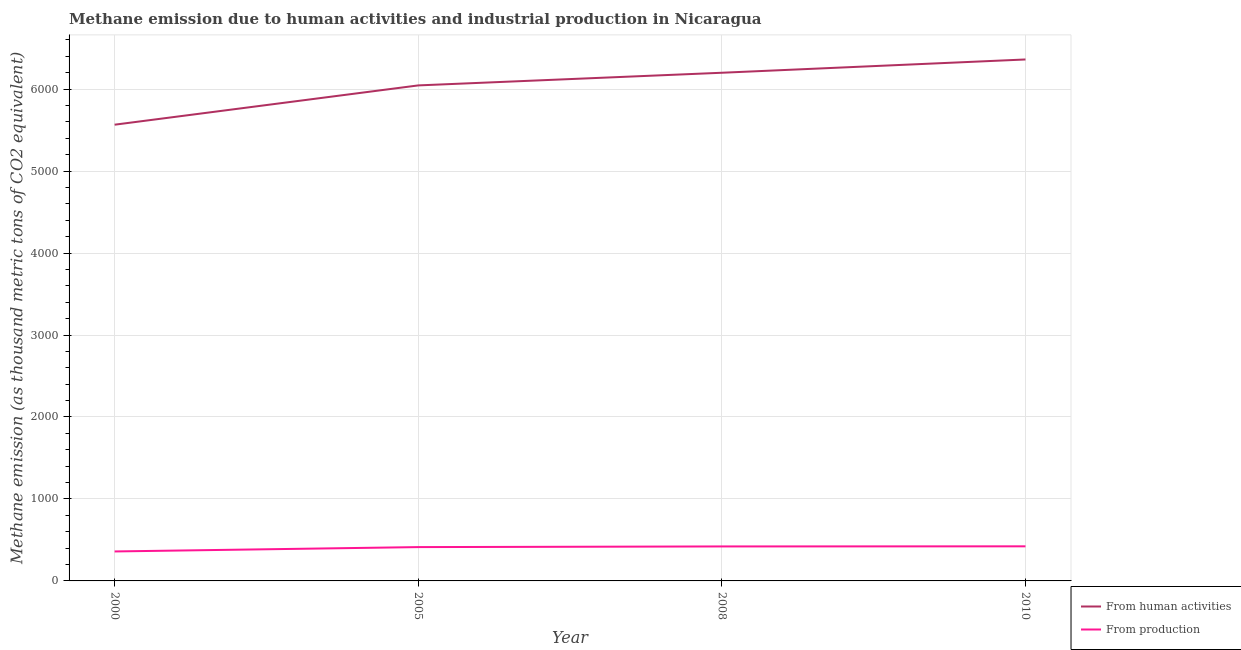Does the line corresponding to amount of emissions generated from industries intersect with the line corresponding to amount of emissions from human activities?
Provide a succinct answer. No. Is the number of lines equal to the number of legend labels?
Your response must be concise. Yes. What is the amount of emissions from human activities in 2000?
Your answer should be very brief. 5565.7. Across all years, what is the maximum amount of emissions generated from industries?
Provide a short and direct response. 422.1. Across all years, what is the minimum amount of emissions generated from industries?
Give a very brief answer. 359.5. In which year was the amount of emissions from human activities maximum?
Ensure brevity in your answer.  2010. What is the total amount of emissions from human activities in the graph?
Your response must be concise. 2.42e+04. What is the difference between the amount of emissions from human activities in 2008 and that in 2010?
Provide a short and direct response. -161.9. What is the difference between the amount of emissions generated from industries in 2010 and the amount of emissions from human activities in 2005?
Give a very brief answer. -5622.9. What is the average amount of emissions from human activities per year?
Your answer should be compact. 6042.9. In the year 2010, what is the difference between the amount of emissions generated from industries and amount of emissions from human activities?
Your response must be concise. -5939.3. In how many years, is the amount of emissions from human activities greater than 1000 thousand metric tons?
Your response must be concise. 4. What is the ratio of the amount of emissions generated from industries in 2005 to that in 2010?
Offer a terse response. 0.98. What is the difference between the highest and the second highest amount of emissions from human activities?
Your answer should be very brief. 161.9. What is the difference between the highest and the lowest amount of emissions generated from industries?
Provide a short and direct response. 62.6. In how many years, is the amount of emissions from human activities greater than the average amount of emissions from human activities taken over all years?
Offer a terse response. 3. Is the sum of the amount of emissions generated from industries in 2000 and 2008 greater than the maximum amount of emissions from human activities across all years?
Make the answer very short. No. Does the amount of emissions generated from industries monotonically increase over the years?
Offer a very short reply. Yes. Is the amount of emissions generated from industries strictly greater than the amount of emissions from human activities over the years?
Your answer should be compact. No. How many years are there in the graph?
Keep it short and to the point. 4. Are the values on the major ticks of Y-axis written in scientific E-notation?
Provide a short and direct response. No. How many legend labels are there?
Make the answer very short. 2. What is the title of the graph?
Your answer should be very brief. Methane emission due to human activities and industrial production in Nicaragua. What is the label or title of the X-axis?
Keep it short and to the point. Year. What is the label or title of the Y-axis?
Give a very brief answer. Methane emission (as thousand metric tons of CO2 equivalent). What is the Methane emission (as thousand metric tons of CO2 equivalent) in From human activities in 2000?
Provide a short and direct response. 5565.7. What is the Methane emission (as thousand metric tons of CO2 equivalent) of From production in 2000?
Give a very brief answer. 359.5. What is the Methane emission (as thousand metric tons of CO2 equivalent) in From human activities in 2005?
Make the answer very short. 6045. What is the Methane emission (as thousand metric tons of CO2 equivalent) in From production in 2005?
Give a very brief answer. 412.7. What is the Methane emission (as thousand metric tons of CO2 equivalent) in From human activities in 2008?
Give a very brief answer. 6199.5. What is the Methane emission (as thousand metric tons of CO2 equivalent) in From production in 2008?
Your answer should be very brief. 420.7. What is the Methane emission (as thousand metric tons of CO2 equivalent) in From human activities in 2010?
Provide a short and direct response. 6361.4. What is the Methane emission (as thousand metric tons of CO2 equivalent) of From production in 2010?
Make the answer very short. 422.1. Across all years, what is the maximum Methane emission (as thousand metric tons of CO2 equivalent) in From human activities?
Offer a terse response. 6361.4. Across all years, what is the maximum Methane emission (as thousand metric tons of CO2 equivalent) of From production?
Your answer should be very brief. 422.1. Across all years, what is the minimum Methane emission (as thousand metric tons of CO2 equivalent) in From human activities?
Make the answer very short. 5565.7. Across all years, what is the minimum Methane emission (as thousand metric tons of CO2 equivalent) in From production?
Make the answer very short. 359.5. What is the total Methane emission (as thousand metric tons of CO2 equivalent) in From human activities in the graph?
Make the answer very short. 2.42e+04. What is the total Methane emission (as thousand metric tons of CO2 equivalent) in From production in the graph?
Offer a very short reply. 1615. What is the difference between the Methane emission (as thousand metric tons of CO2 equivalent) of From human activities in 2000 and that in 2005?
Provide a succinct answer. -479.3. What is the difference between the Methane emission (as thousand metric tons of CO2 equivalent) of From production in 2000 and that in 2005?
Your answer should be compact. -53.2. What is the difference between the Methane emission (as thousand metric tons of CO2 equivalent) in From human activities in 2000 and that in 2008?
Offer a terse response. -633.8. What is the difference between the Methane emission (as thousand metric tons of CO2 equivalent) in From production in 2000 and that in 2008?
Provide a short and direct response. -61.2. What is the difference between the Methane emission (as thousand metric tons of CO2 equivalent) of From human activities in 2000 and that in 2010?
Keep it short and to the point. -795.7. What is the difference between the Methane emission (as thousand metric tons of CO2 equivalent) in From production in 2000 and that in 2010?
Your answer should be compact. -62.6. What is the difference between the Methane emission (as thousand metric tons of CO2 equivalent) of From human activities in 2005 and that in 2008?
Your answer should be compact. -154.5. What is the difference between the Methane emission (as thousand metric tons of CO2 equivalent) in From human activities in 2005 and that in 2010?
Your answer should be compact. -316.4. What is the difference between the Methane emission (as thousand metric tons of CO2 equivalent) in From human activities in 2008 and that in 2010?
Offer a very short reply. -161.9. What is the difference between the Methane emission (as thousand metric tons of CO2 equivalent) of From production in 2008 and that in 2010?
Ensure brevity in your answer.  -1.4. What is the difference between the Methane emission (as thousand metric tons of CO2 equivalent) in From human activities in 2000 and the Methane emission (as thousand metric tons of CO2 equivalent) in From production in 2005?
Ensure brevity in your answer.  5153. What is the difference between the Methane emission (as thousand metric tons of CO2 equivalent) in From human activities in 2000 and the Methane emission (as thousand metric tons of CO2 equivalent) in From production in 2008?
Ensure brevity in your answer.  5145. What is the difference between the Methane emission (as thousand metric tons of CO2 equivalent) of From human activities in 2000 and the Methane emission (as thousand metric tons of CO2 equivalent) of From production in 2010?
Offer a terse response. 5143.6. What is the difference between the Methane emission (as thousand metric tons of CO2 equivalent) of From human activities in 2005 and the Methane emission (as thousand metric tons of CO2 equivalent) of From production in 2008?
Give a very brief answer. 5624.3. What is the difference between the Methane emission (as thousand metric tons of CO2 equivalent) in From human activities in 2005 and the Methane emission (as thousand metric tons of CO2 equivalent) in From production in 2010?
Give a very brief answer. 5622.9. What is the difference between the Methane emission (as thousand metric tons of CO2 equivalent) in From human activities in 2008 and the Methane emission (as thousand metric tons of CO2 equivalent) in From production in 2010?
Your answer should be very brief. 5777.4. What is the average Methane emission (as thousand metric tons of CO2 equivalent) of From human activities per year?
Offer a very short reply. 6042.9. What is the average Methane emission (as thousand metric tons of CO2 equivalent) of From production per year?
Offer a terse response. 403.75. In the year 2000, what is the difference between the Methane emission (as thousand metric tons of CO2 equivalent) in From human activities and Methane emission (as thousand metric tons of CO2 equivalent) in From production?
Your answer should be compact. 5206.2. In the year 2005, what is the difference between the Methane emission (as thousand metric tons of CO2 equivalent) in From human activities and Methane emission (as thousand metric tons of CO2 equivalent) in From production?
Offer a very short reply. 5632.3. In the year 2008, what is the difference between the Methane emission (as thousand metric tons of CO2 equivalent) in From human activities and Methane emission (as thousand metric tons of CO2 equivalent) in From production?
Offer a very short reply. 5778.8. In the year 2010, what is the difference between the Methane emission (as thousand metric tons of CO2 equivalent) of From human activities and Methane emission (as thousand metric tons of CO2 equivalent) of From production?
Provide a short and direct response. 5939.3. What is the ratio of the Methane emission (as thousand metric tons of CO2 equivalent) in From human activities in 2000 to that in 2005?
Offer a very short reply. 0.92. What is the ratio of the Methane emission (as thousand metric tons of CO2 equivalent) in From production in 2000 to that in 2005?
Give a very brief answer. 0.87. What is the ratio of the Methane emission (as thousand metric tons of CO2 equivalent) in From human activities in 2000 to that in 2008?
Give a very brief answer. 0.9. What is the ratio of the Methane emission (as thousand metric tons of CO2 equivalent) in From production in 2000 to that in 2008?
Offer a very short reply. 0.85. What is the ratio of the Methane emission (as thousand metric tons of CO2 equivalent) of From human activities in 2000 to that in 2010?
Give a very brief answer. 0.87. What is the ratio of the Methane emission (as thousand metric tons of CO2 equivalent) of From production in 2000 to that in 2010?
Your answer should be compact. 0.85. What is the ratio of the Methane emission (as thousand metric tons of CO2 equivalent) in From human activities in 2005 to that in 2008?
Give a very brief answer. 0.98. What is the ratio of the Methane emission (as thousand metric tons of CO2 equivalent) of From production in 2005 to that in 2008?
Ensure brevity in your answer.  0.98. What is the ratio of the Methane emission (as thousand metric tons of CO2 equivalent) in From human activities in 2005 to that in 2010?
Keep it short and to the point. 0.95. What is the ratio of the Methane emission (as thousand metric tons of CO2 equivalent) in From production in 2005 to that in 2010?
Offer a very short reply. 0.98. What is the ratio of the Methane emission (as thousand metric tons of CO2 equivalent) in From human activities in 2008 to that in 2010?
Provide a succinct answer. 0.97. What is the difference between the highest and the second highest Methane emission (as thousand metric tons of CO2 equivalent) in From human activities?
Your answer should be compact. 161.9. What is the difference between the highest and the lowest Methane emission (as thousand metric tons of CO2 equivalent) in From human activities?
Offer a terse response. 795.7. What is the difference between the highest and the lowest Methane emission (as thousand metric tons of CO2 equivalent) in From production?
Offer a terse response. 62.6. 